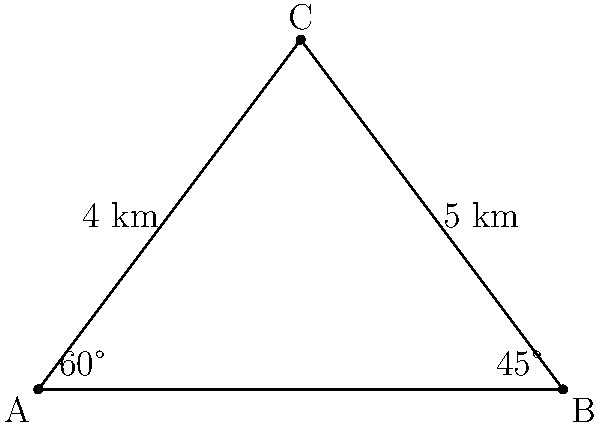As a project manager planning a family vacation, you're estimating wait times for attractions based on queue lengths. The diagram represents three popular attractions (A, B, and C) in a theme park. If the average wait time is proportional to the distance between attractions, and you know that the wait time between A and B is 60 minutes, what is the estimated wait time (in minutes) for the queue between B and C? Let's approach this step-by-step:

1) First, we need to understand the relationship between distance and wait time. We're told that the wait time is proportional to the distance.

2) We can see that the distance AB is 6 km (the base of the triangle), and this corresponds to a 60-minute wait.

3) So, we can establish the ratio: 6 km = 60 minutes

4) Now, we need to find the length of BC. We can do this using the Pythagorean theorem:

   $BC^2 = AC^2 - AB^2$

5) We're given that AC = 5 km and AB = 6 km. Let's substitute these values:

   $BC^2 = 5^2 - 6^2 = 25 - 36 = -11$

6) Taking the square root:

   $BC = \sqrt{11} \approx 3.32$ km

7) Now we can set up a proportion to find the wait time for BC:

   $\frac{6 \text{ km}}{60 \text{ minutes}} = \frac{3.32 \text{ km}}{x \text{ minutes}}$

8) Cross multiply:

   $6x = 60 * 3.32$

9) Solve for x:

   $x = \frac{60 * 3.32}{6} = 33.2$ minutes

10) Rounding to the nearest minute: 33 minutes
Answer: 33 minutes 